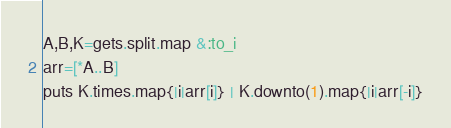Convert code to text. <code><loc_0><loc_0><loc_500><loc_500><_Ruby_>A,B,K=gets.split.map &:to_i
arr=[*A..B]
puts K.times.map{|i|arr[i]} | K.downto(1).map{|i|arr[-i]}</code> 